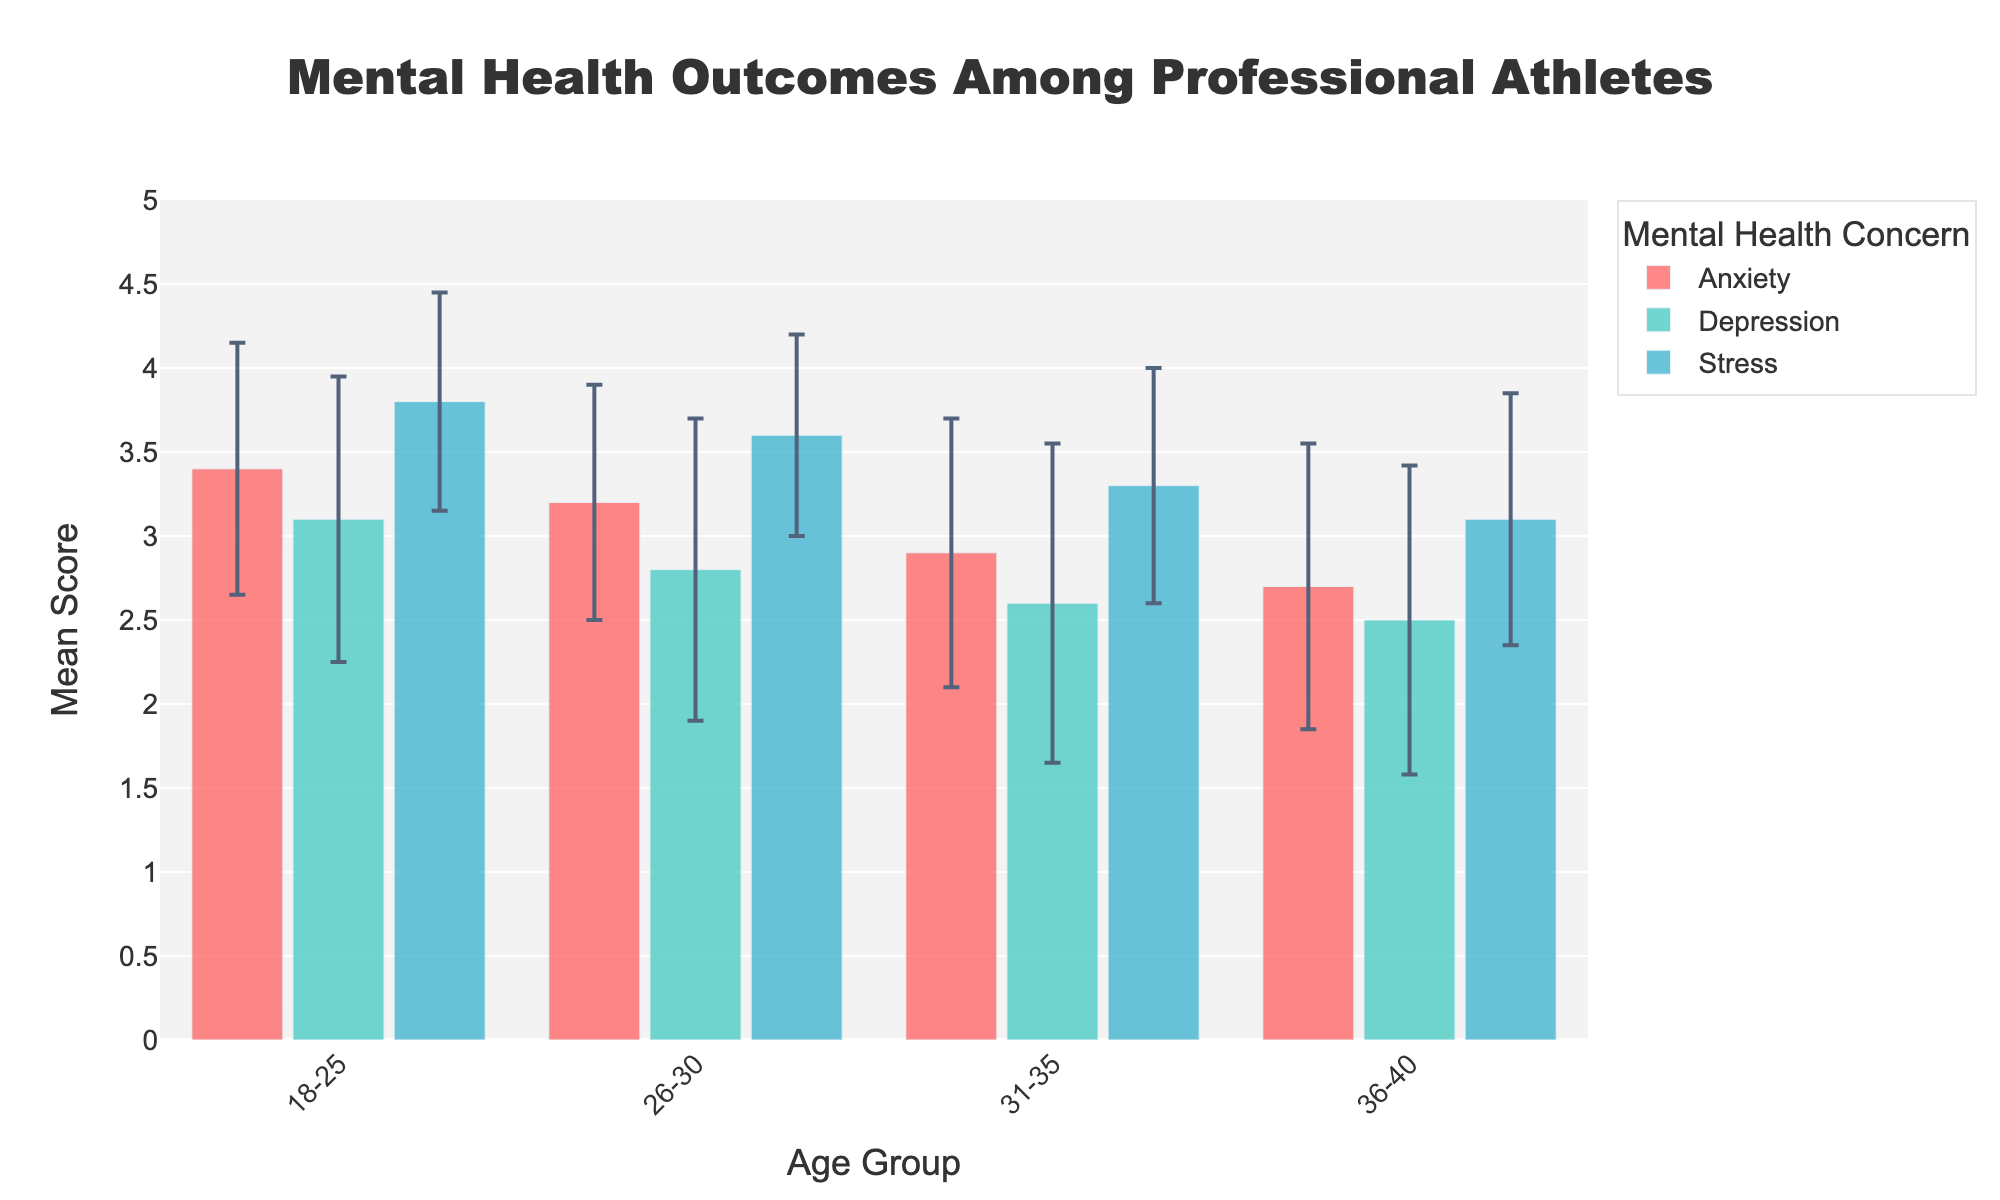What's the title of the figure? The title is located at the top center of the figure. It reads: 'Mental Health Outcomes Among Professional Athletes'.
Answer: Mental Health Outcomes Among Professional Athletes What is the general trend in mean scores of stress across different age groups? The mean scores for stress decrease as age increases: 18-25 (3.8), 26-30 (3.6), 31-35 (3.3), and 36-40 (3.1).
Answer: Decreasing Which mental health concern has the highest mean score in the 18-25 age group? The highest mean score in the 18-25 age group is for stress, with a score of 3.8.
Answer: Stress Which age group shows the lowest mean score for depression? The age group 36-40 shows the lowest mean score for depression at 2.5.
Answer: 36-40 Compare anxiety levels between the 18-25 and 31-35 age groups. Which has higher mean scores and by how much? The mean score for anxiety in 18-25 is 3.4, while in 31-35, it is 2.9. The 18-25 group has a higher mean score by 0.5.
Answer: 18-25, by 0.5 How do the error bars for stress in the 26-30 age group compare to those in the 36-40 age group? The error bars for stress in the 26-30 age group (0.60) are shorter than those in the 36-40 age group (0.75), indicating less variability in the 26-30 group.
Answer: Shorter, less variability What is the average of the mean scores for anxiety across all age groups? Sum the mean scores for anxiety (3.4 + 3.2 + 2.9 + 2.7) which equals 12.2, then divide by 4 age groups to get 12.2 / 4 = 3.05.
Answer: 3.05 Which age group has the smallest standard deviation for anxiety, and what is the value? The age group 26-30 shows the smallest standard deviation for anxiety, which is 0.70.
Answer: 26-30, 0.70 Is the mean score for depression in the 26-30 age group higher or lower than the mean score for anxiety in the same group, and by how much? The mean score for depression in the 26-30 age group is 2.8, whereas the mean score for anxiety is 3.2. So, the mean score for depression is lower by 0.4.
Answer: Lower, by 0.4 